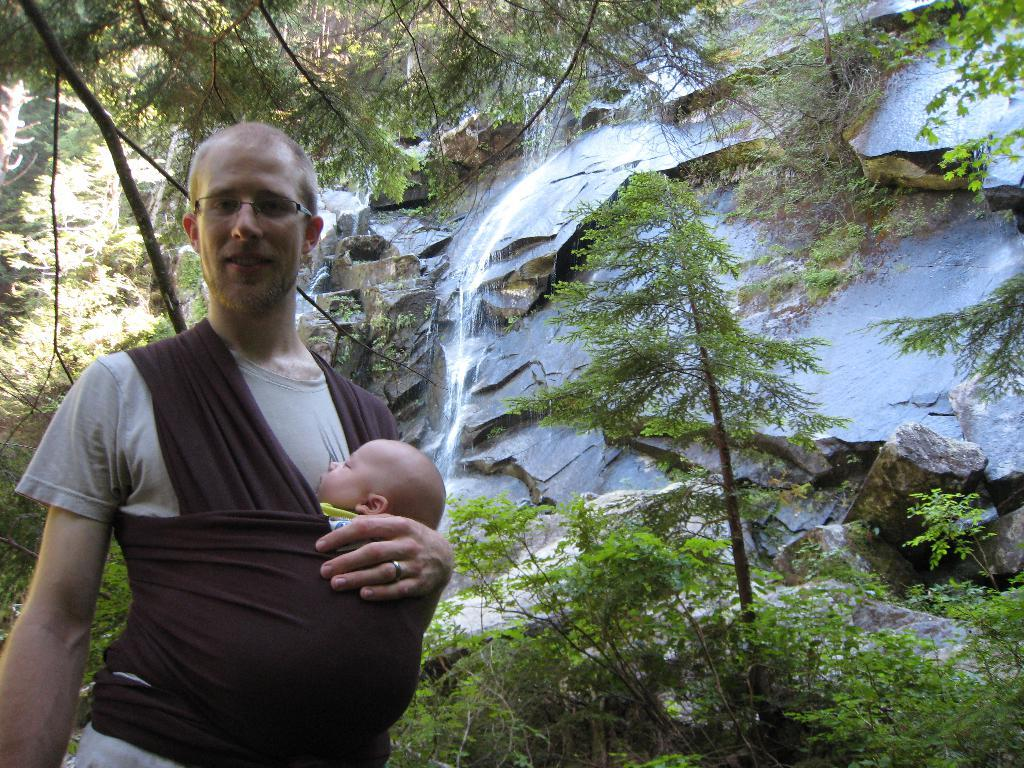Who is the main subject in the image? There is a man in the image. What is the man doing in the image? The man is holding a baby. What can be seen behind the man? There is a cloth behind the man. What type of natural scenery is visible in the image? There are trees and a waterfall on rocks in the image. What type of corn can be seen growing on the side of the waterfall in the image? There is no corn visible in the image, nor is there any corn growing on the side of the waterfall. 